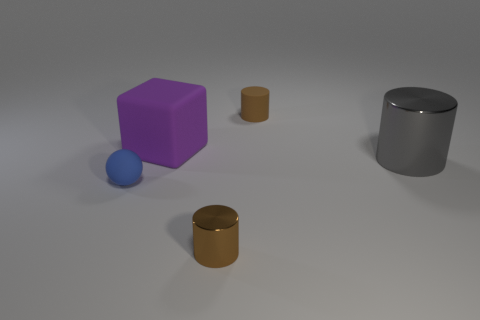Add 3 green shiny blocks. How many objects exist? 8 Subtract all cylinders. How many objects are left? 2 Subtract 0 yellow balls. How many objects are left? 5 Subtract all rubber blocks. Subtract all gray shiny cylinders. How many objects are left? 3 Add 3 blue rubber balls. How many blue rubber balls are left? 4 Add 2 large gray things. How many large gray things exist? 3 